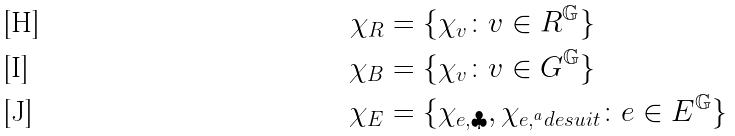Convert formula to latex. <formula><loc_0><loc_0><loc_500><loc_500>\chi _ { R } & = \{ \chi _ { v } \colon v \in R ^ { \mathbb { G } } \} \\ \chi _ { B } & = \{ \chi _ { v } \colon v \in G ^ { \mathbb { G } } \} \\ \chi _ { E } & = \{ \chi _ { e , \clubsuit } , \chi _ { e , ^ { a } d e s u i t } \colon e \in E ^ { \mathbb { G } } \}</formula> 